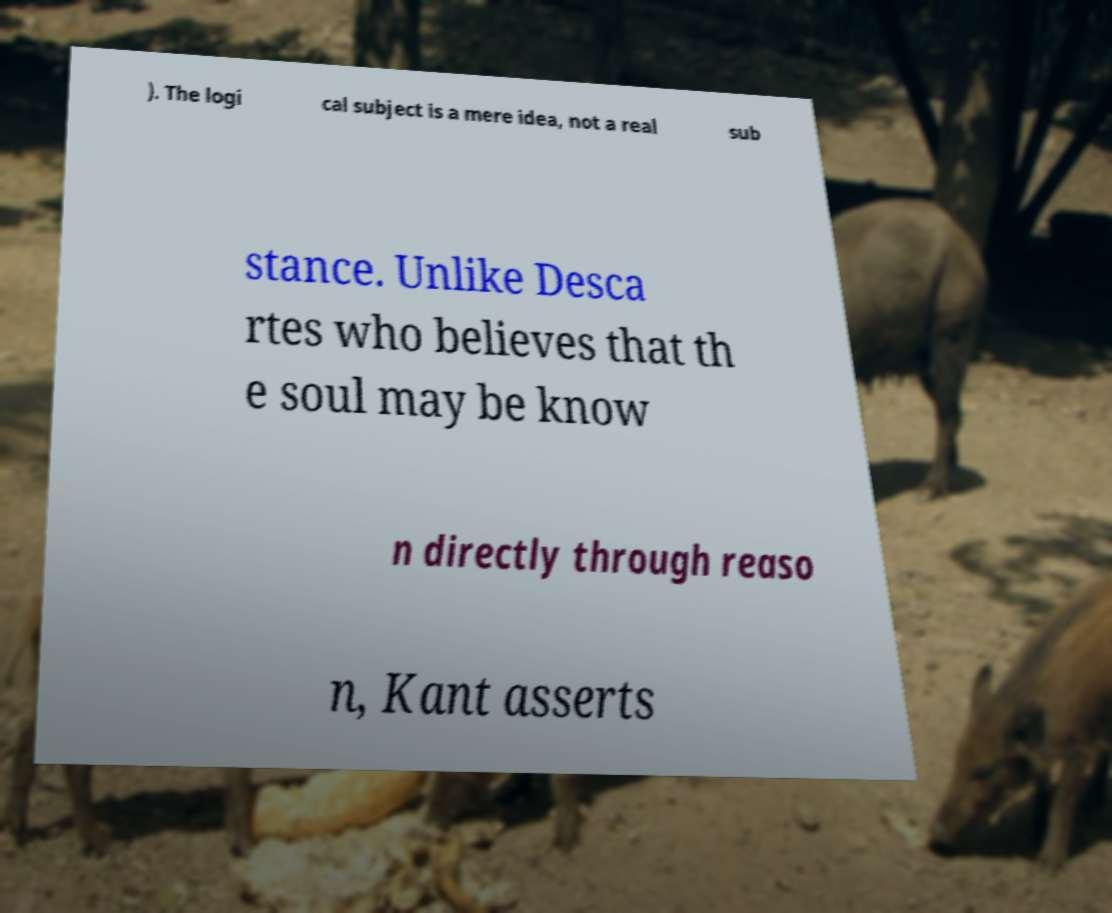There's text embedded in this image that I need extracted. Can you transcribe it verbatim? ). The logi cal subject is a mere idea, not a real sub stance. Unlike Desca rtes who believes that th e soul may be know n directly through reaso n, Kant asserts 